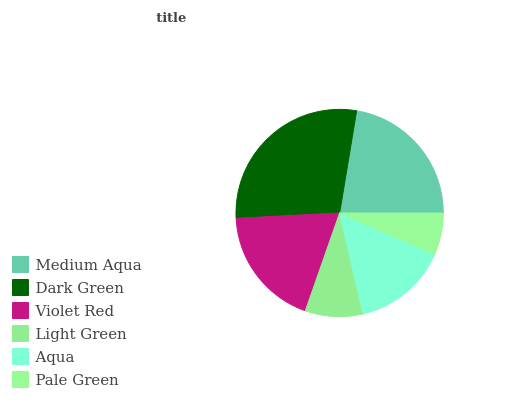Is Pale Green the minimum?
Answer yes or no. Yes. Is Dark Green the maximum?
Answer yes or no. Yes. Is Violet Red the minimum?
Answer yes or no. No. Is Violet Red the maximum?
Answer yes or no. No. Is Dark Green greater than Violet Red?
Answer yes or no. Yes. Is Violet Red less than Dark Green?
Answer yes or no. Yes. Is Violet Red greater than Dark Green?
Answer yes or no. No. Is Dark Green less than Violet Red?
Answer yes or no. No. Is Violet Red the high median?
Answer yes or no. Yes. Is Aqua the low median?
Answer yes or no. Yes. Is Aqua the high median?
Answer yes or no. No. Is Dark Green the low median?
Answer yes or no. No. 